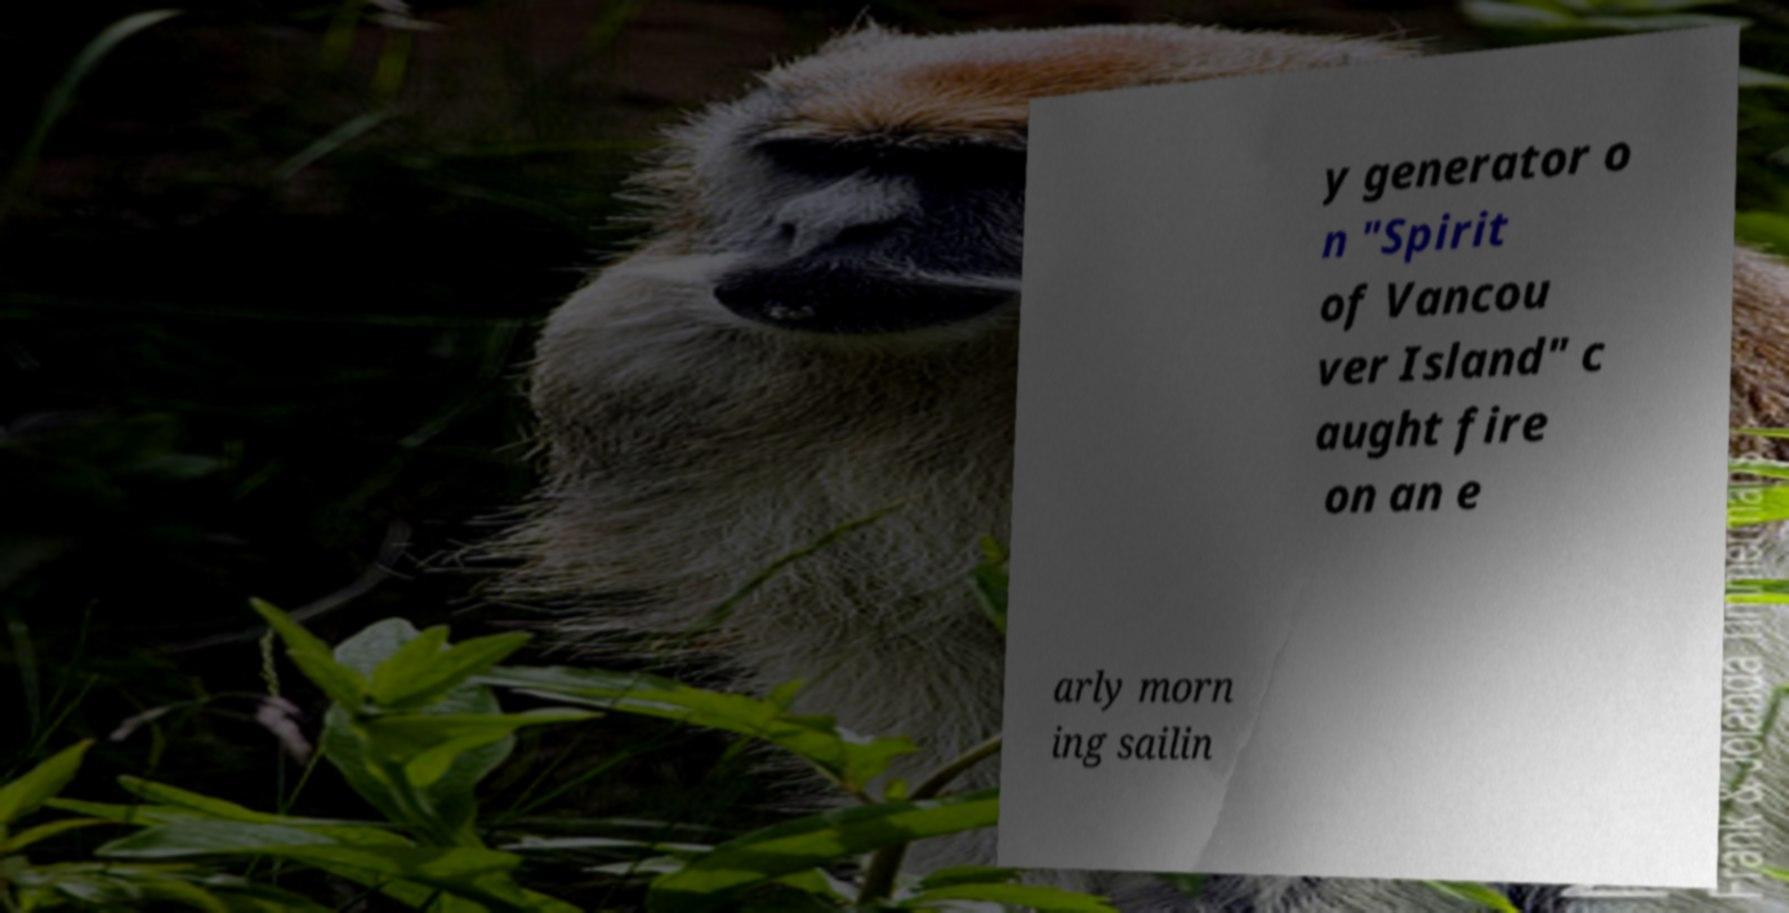Can you accurately transcribe the text from the provided image for me? y generator o n "Spirit of Vancou ver Island" c aught fire on an e arly morn ing sailin 